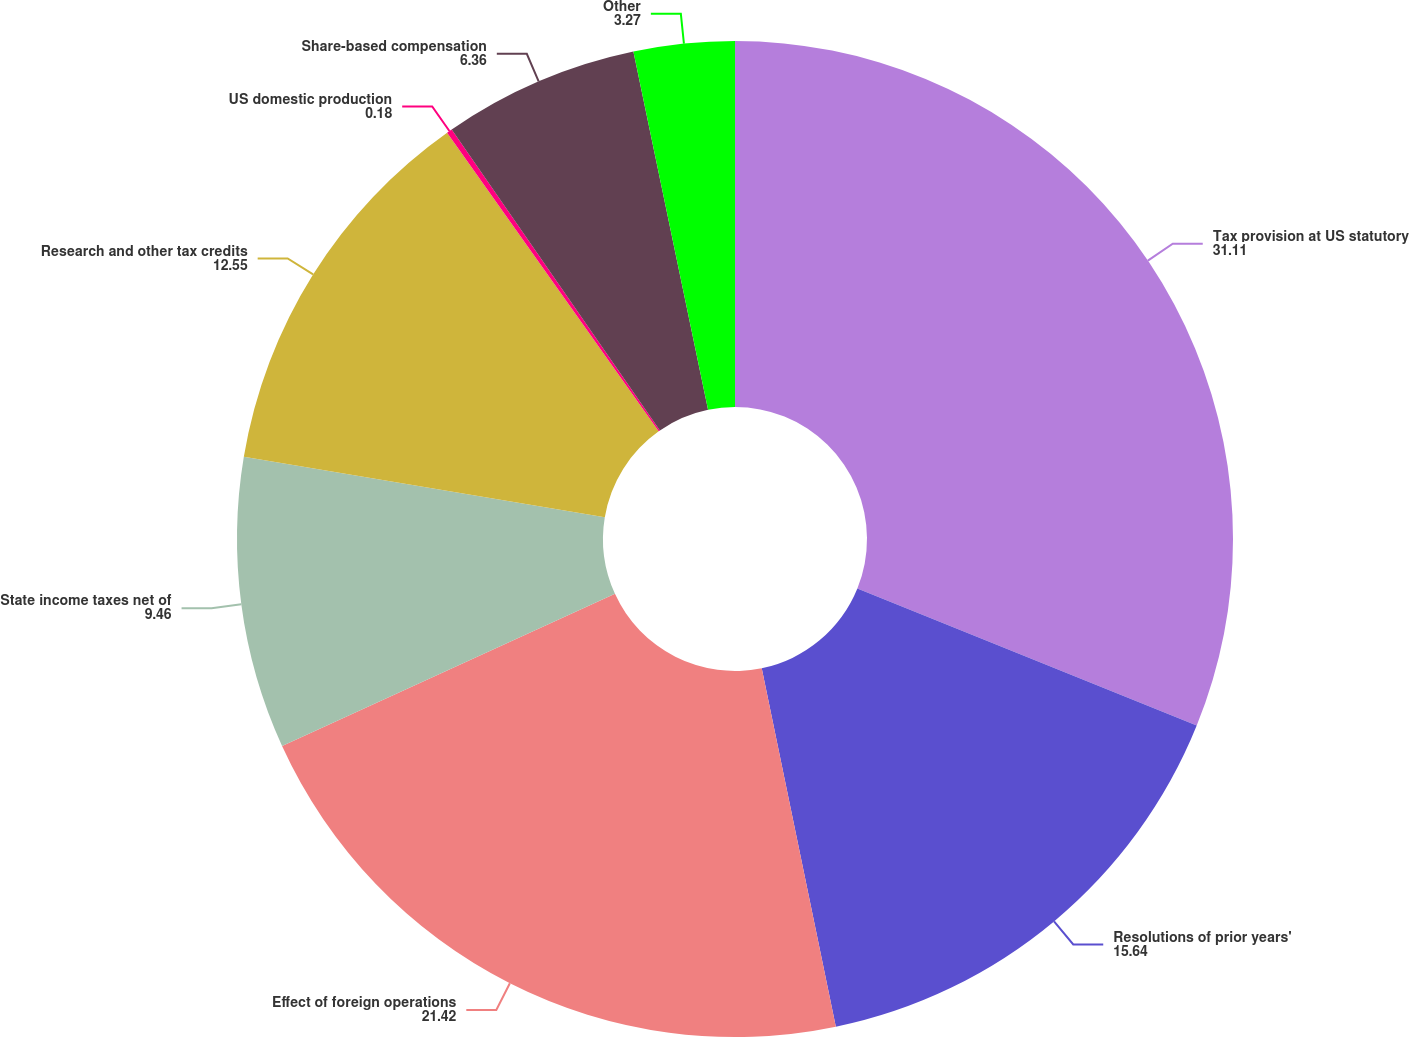Convert chart to OTSL. <chart><loc_0><loc_0><loc_500><loc_500><pie_chart><fcel>Tax provision at US statutory<fcel>Resolutions of prior years'<fcel>Effect of foreign operations<fcel>State income taxes net of<fcel>Research and other tax credits<fcel>US domestic production<fcel>Share-based compensation<fcel>Other<nl><fcel>31.11%<fcel>15.64%<fcel>21.42%<fcel>9.46%<fcel>12.55%<fcel>0.18%<fcel>6.36%<fcel>3.27%<nl></chart> 